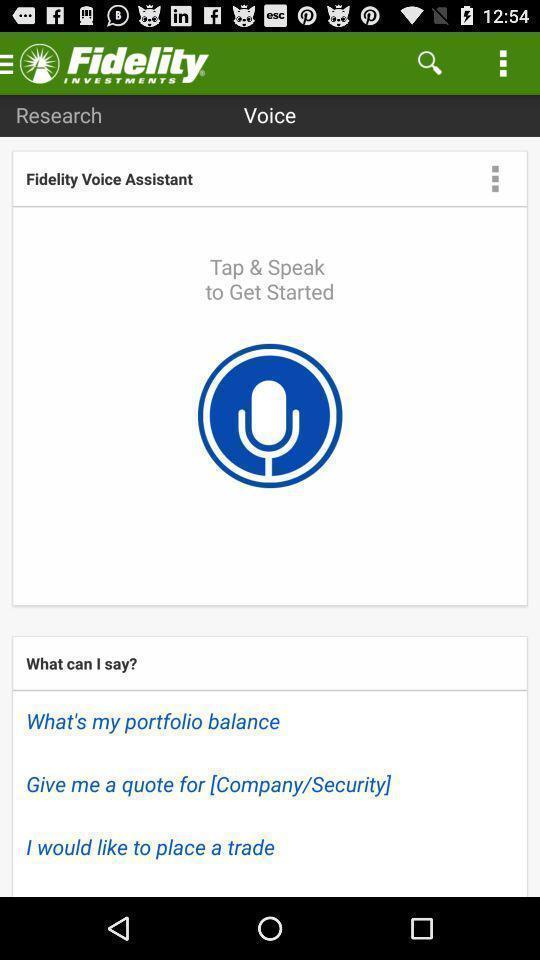Explain what's happening in this screen capture. Voice assistant page of an investment app. 